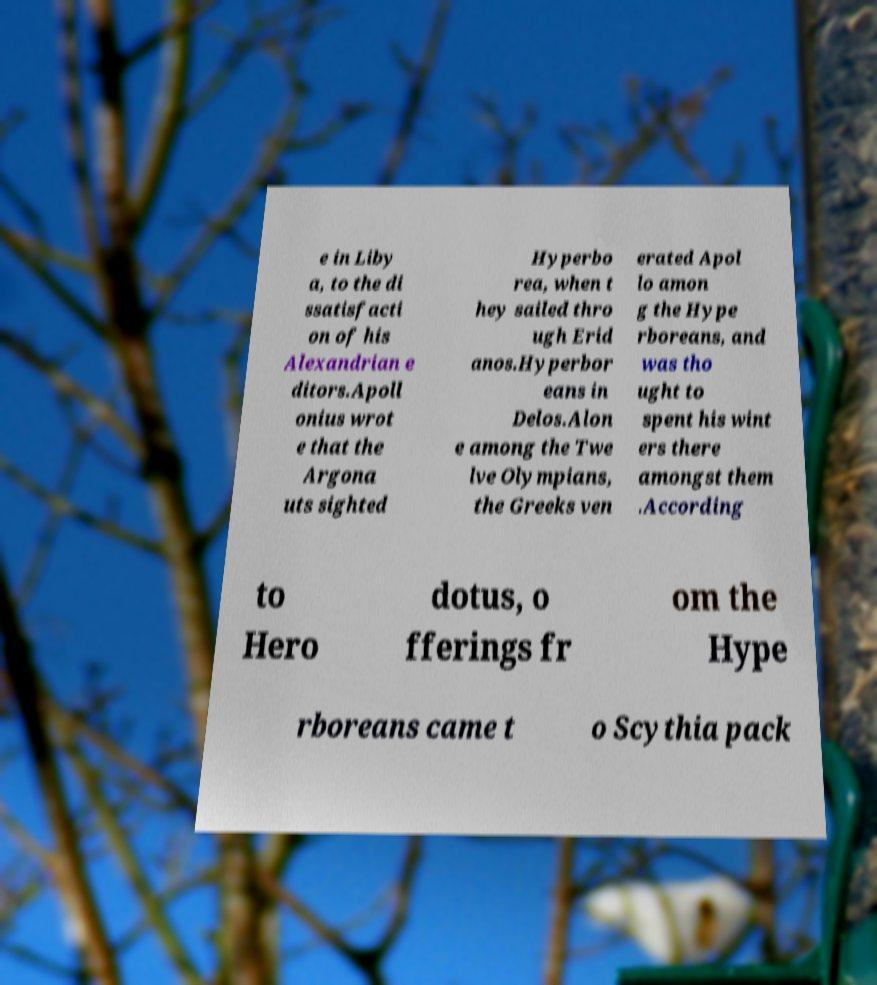Please read and relay the text visible in this image. What does it say? e in Liby a, to the di ssatisfacti on of his Alexandrian e ditors.Apoll onius wrot e that the Argona uts sighted Hyperbo rea, when t hey sailed thro ugh Erid anos.Hyperbor eans in Delos.Alon e among the Twe lve Olympians, the Greeks ven erated Apol lo amon g the Hype rboreans, and was tho ught to spent his wint ers there amongst them .According to Hero dotus, o fferings fr om the Hype rboreans came t o Scythia pack 